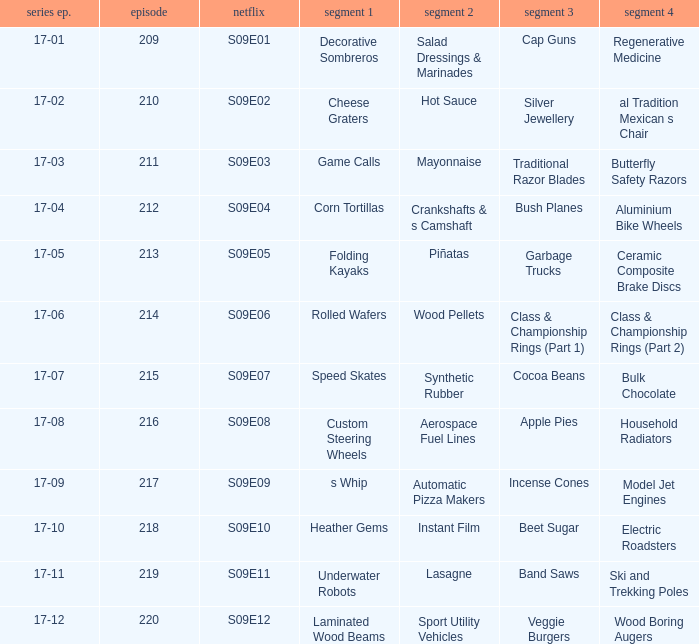Are rolled wafers in many episodes 17-06. 